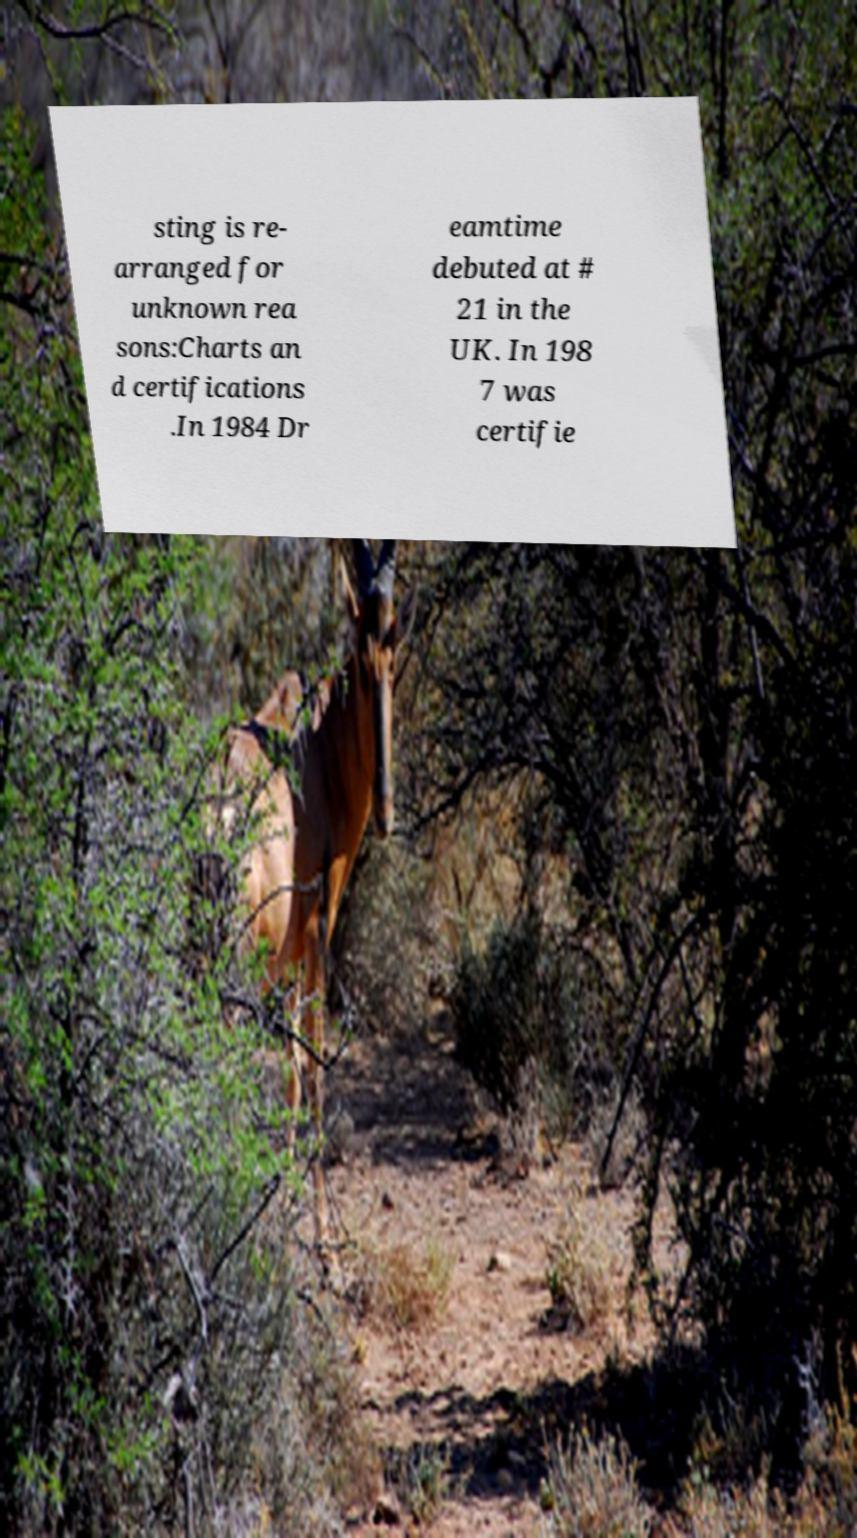Please read and relay the text visible in this image. What does it say? sting is re- arranged for unknown rea sons:Charts an d certifications .In 1984 Dr eamtime debuted at # 21 in the UK. In 198 7 was certifie 